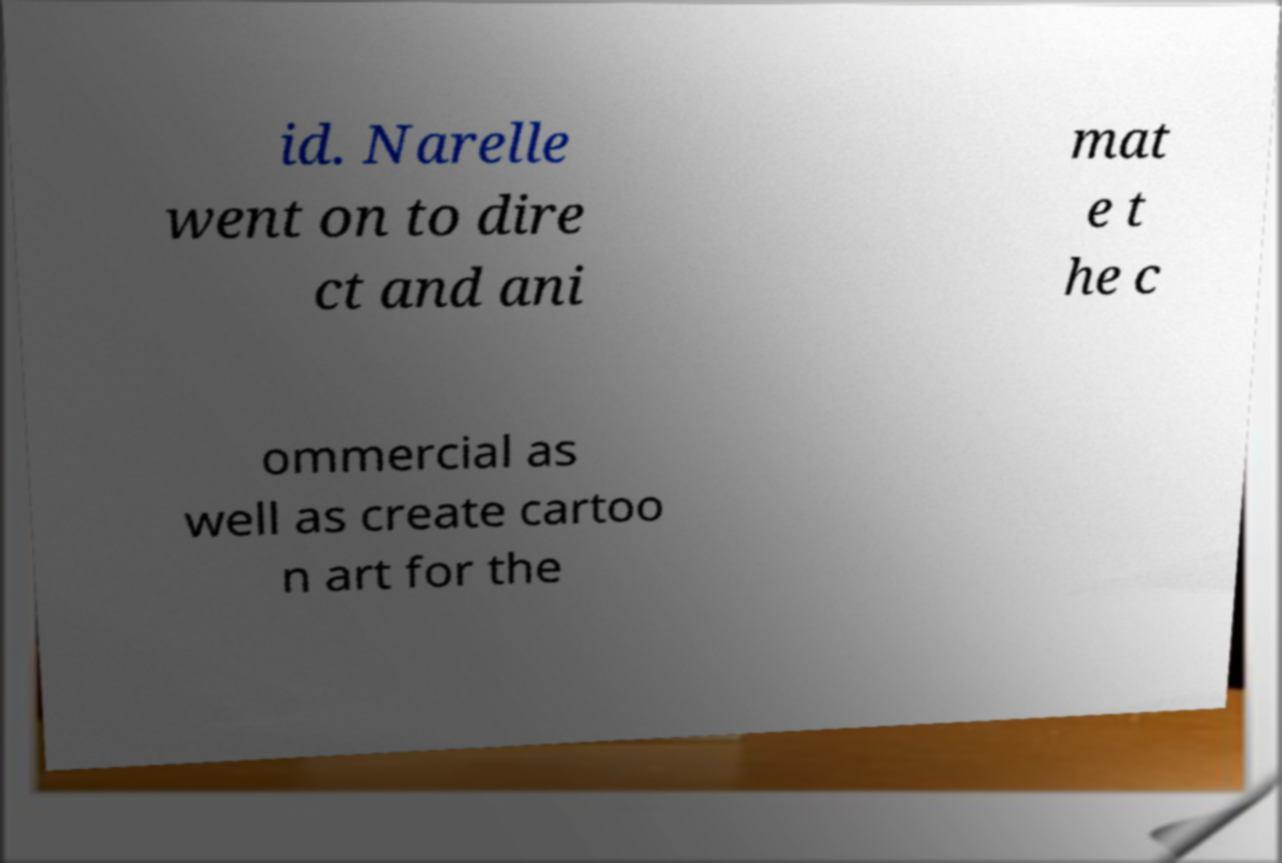What messages or text are displayed in this image? I need them in a readable, typed format. id. Narelle went on to dire ct and ani mat e t he c ommercial as well as create cartoo n art for the 